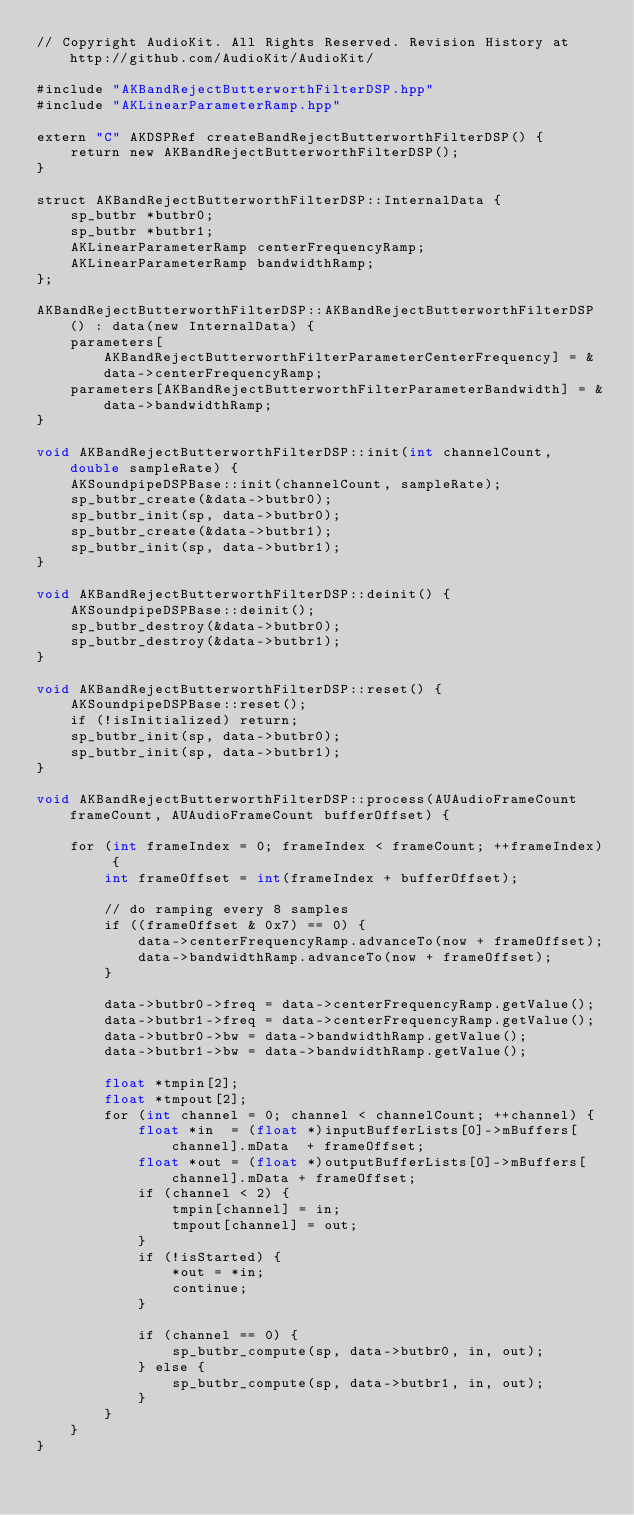Convert code to text. <code><loc_0><loc_0><loc_500><loc_500><_ObjectiveC_>// Copyright AudioKit. All Rights Reserved. Revision History at http://github.com/AudioKit/AudioKit/

#include "AKBandRejectButterworthFilterDSP.hpp"
#include "AKLinearParameterRamp.hpp"

extern "C" AKDSPRef createBandRejectButterworthFilterDSP() {
    return new AKBandRejectButterworthFilterDSP();
}

struct AKBandRejectButterworthFilterDSP::InternalData {
    sp_butbr *butbr0;
    sp_butbr *butbr1;
    AKLinearParameterRamp centerFrequencyRamp;
    AKLinearParameterRamp bandwidthRamp;
};

AKBandRejectButterworthFilterDSP::AKBandRejectButterworthFilterDSP() : data(new InternalData) {
    parameters[AKBandRejectButterworthFilterParameterCenterFrequency] = &data->centerFrequencyRamp;
    parameters[AKBandRejectButterworthFilterParameterBandwidth] = &data->bandwidthRamp;
}

void AKBandRejectButterworthFilterDSP::init(int channelCount, double sampleRate) {
    AKSoundpipeDSPBase::init(channelCount, sampleRate);
    sp_butbr_create(&data->butbr0);
    sp_butbr_init(sp, data->butbr0);
    sp_butbr_create(&data->butbr1);
    sp_butbr_init(sp, data->butbr1);
}

void AKBandRejectButterworthFilterDSP::deinit() {
    AKSoundpipeDSPBase::deinit();
    sp_butbr_destroy(&data->butbr0);
    sp_butbr_destroy(&data->butbr1);
}

void AKBandRejectButterworthFilterDSP::reset() {
    AKSoundpipeDSPBase::reset();
    if (!isInitialized) return;
    sp_butbr_init(sp, data->butbr0);
    sp_butbr_init(sp, data->butbr1);
}

void AKBandRejectButterworthFilterDSP::process(AUAudioFrameCount frameCount, AUAudioFrameCount bufferOffset) {

    for (int frameIndex = 0; frameIndex < frameCount; ++frameIndex) {
        int frameOffset = int(frameIndex + bufferOffset);

        // do ramping every 8 samples
        if ((frameOffset & 0x7) == 0) {
            data->centerFrequencyRamp.advanceTo(now + frameOffset);
            data->bandwidthRamp.advanceTo(now + frameOffset);
        }

        data->butbr0->freq = data->centerFrequencyRamp.getValue();
        data->butbr1->freq = data->centerFrequencyRamp.getValue();
        data->butbr0->bw = data->bandwidthRamp.getValue();
        data->butbr1->bw = data->bandwidthRamp.getValue();

        float *tmpin[2];
        float *tmpout[2];
        for (int channel = 0; channel < channelCount; ++channel) {
            float *in  = (float *)inputBufferLists[0]->mBuffers[channel].mData  + frameOffset;
            float *out = (float *)outputBufferLists[0]->mBuffers[channel].mData + frameOffset;
            if (channel < 2) {
                tmpin[channel] = in;
                tmpout[channel] = out;
            }
            if (!isStarted) {
                *out = *in;
                continue;
            }

            if (channel == 0) {
                sp_butbr_compute(sp, data->butbr0, in, out);
            } else {
                sp_butbr_compute(sp, data->butbr1, in, out);
            }
        }
    }
}
</code> 